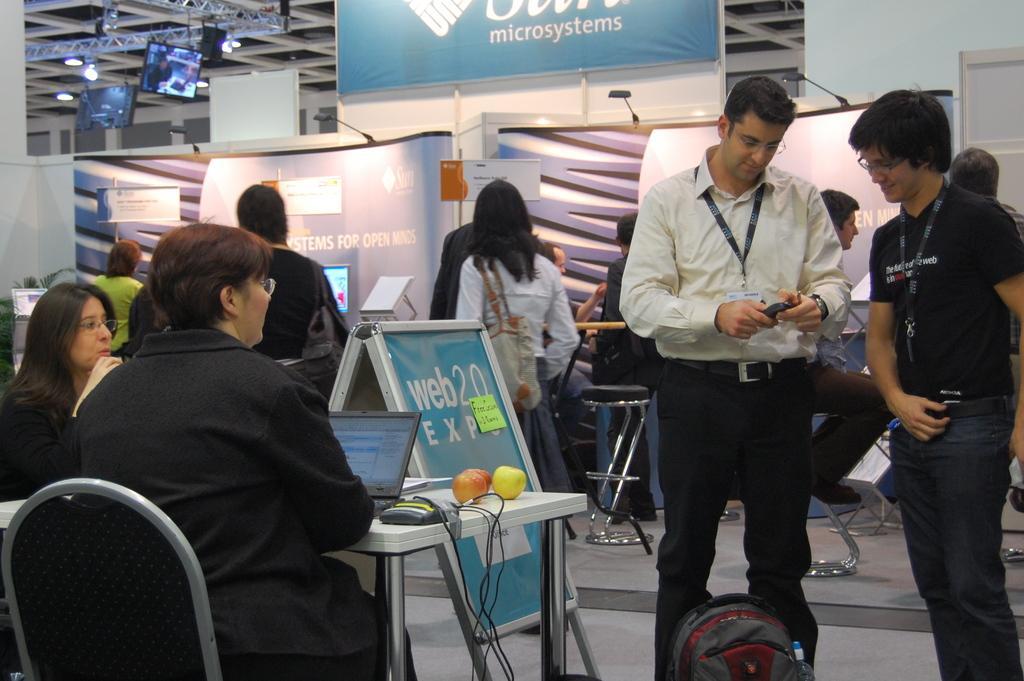Describe this image in one or two sentences. In this image there are group of people. The woman is sitting on the chair. On the table there is a laptop and a fruit. On the floor there is a bag. At the background we can see a board and a light. 